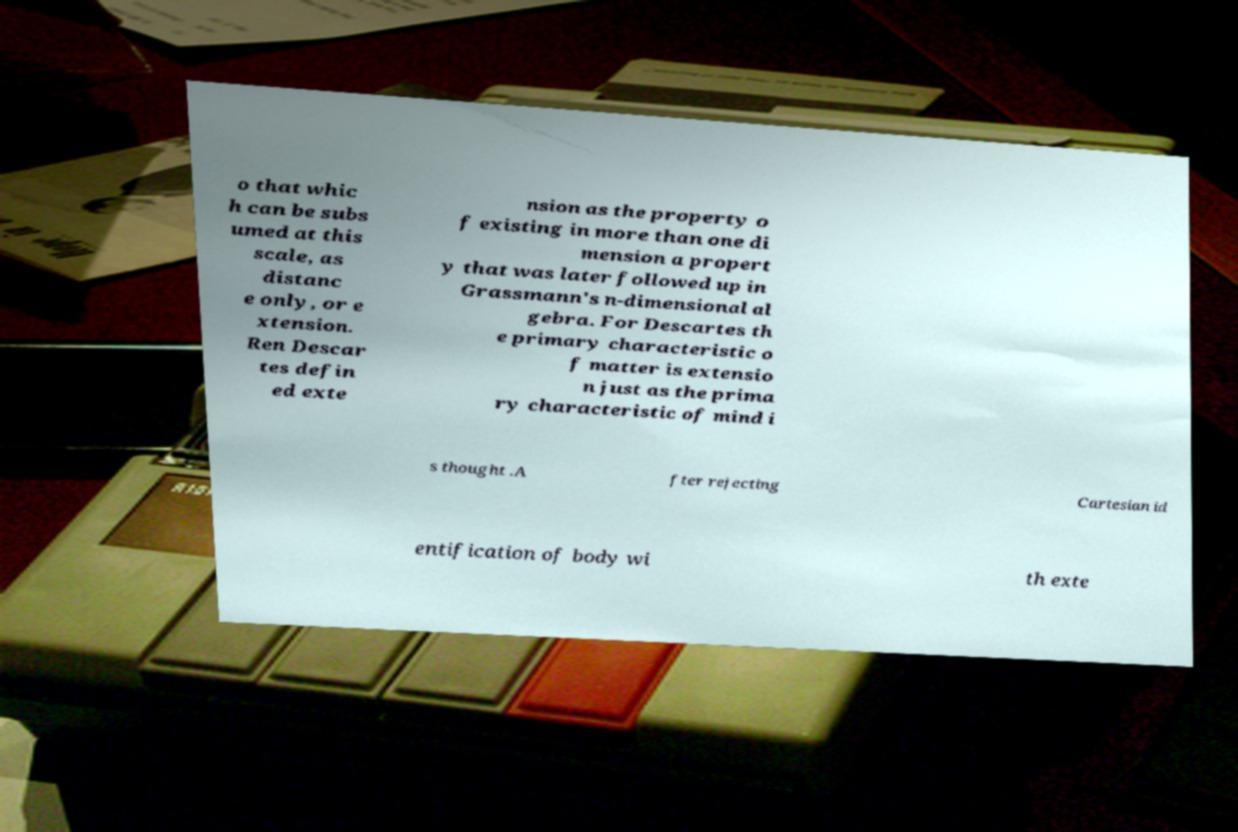Please identify and transcribe the text found in this image. o that whic h can be subs umed at this scale, as distanc e only, or e xtension. Ren Descar tes defin ed exte nsion as the property o f existing in more than one di mension a propert y that was later followed up in Grassmann's n-dimensional al gebra. For Descartes th e primary characteristic o f matter is extensio n just as the prima ry characteristic of mind i s thought .A fter rejecting Cartesian id entification of body wi th exte 